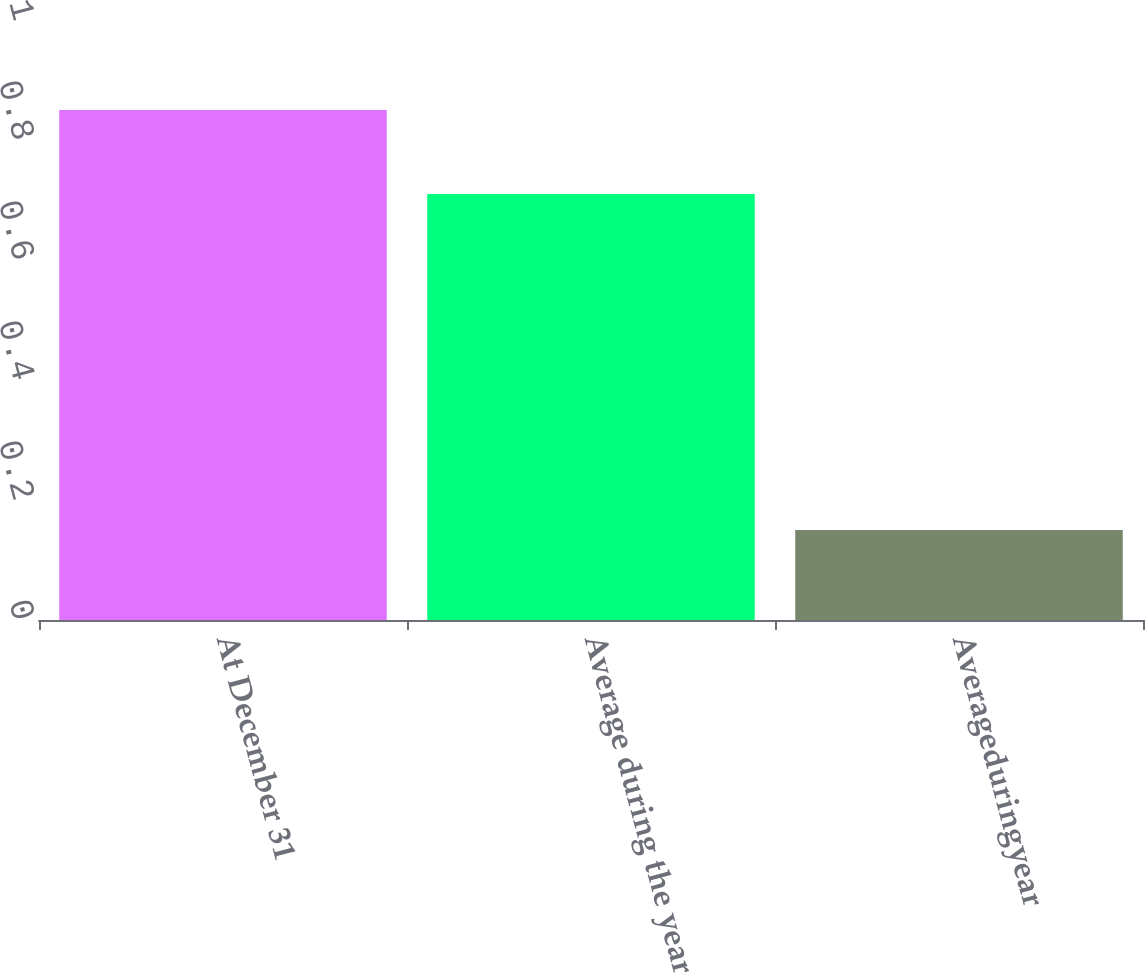Convert chart to OTSL. <chart><loc_0><loc_0><loc_500><loc_500><bar_chart><fcel>At December 31<fcel>Average during the year<fcel>Averageduringyear<nl><fcel>0.85<fcel>0.71<fcel>0.15<nl></chart> 